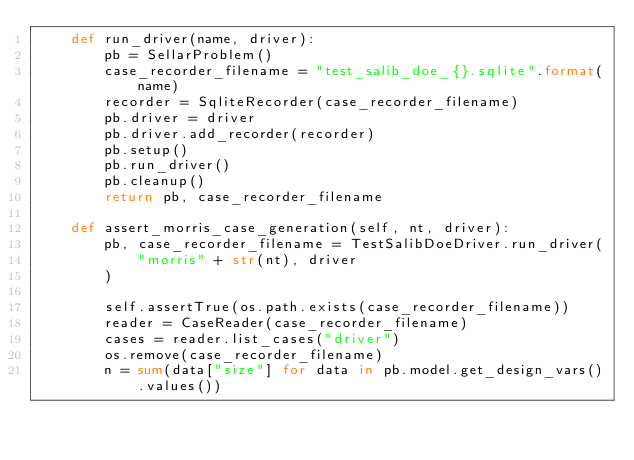<code> <loc_0><loc_0><loc_500><loc_500><_Python_>    def run_driver(name, driver):
        pb = SellarProblem()
        case_recorder_filename = "test_salib_doe_{}.sqlite".format(name)
        recorder = SqliteRecorder(case_recorder_filename)
        pb.driver = driver
        pb.driver.add_recorder(recorder)
        pb.setup()
        pb.run_driver()
        pb.cleanup()
        return pb, case_recorder_filename

    def assert_morris_case_generation(self, nt, driver):
        pb, case_recorder_filename = TestSalibDoeDriver.run_driver(
            "morris" + str(nt), driver
        )

        self.assertTrue(os.path.exists(case_recorder_filename))
        reader = CaseReader(case_recorder_filename)
        cases = reader.list_cases("driver")
        os.remove(case_recorder_filename)
        n = sum(data["size"] for data in pb.model.get_design_vars().values())</code> 